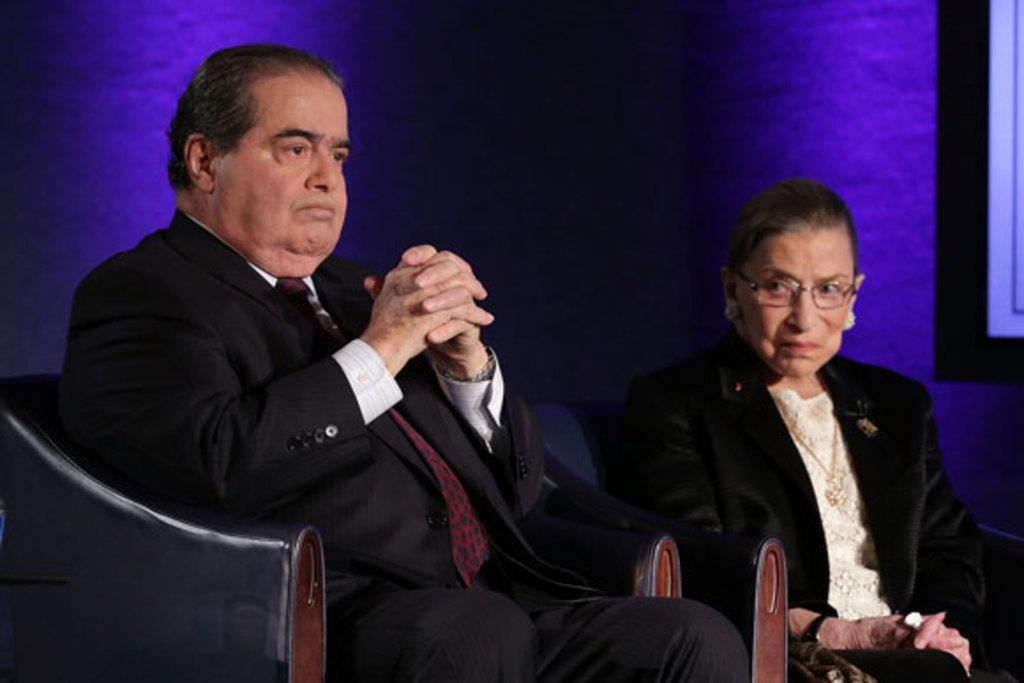Who are the people in the image? There is a man and a woman in the image. What are the man and woman doing in the image? Both the man and woman are sitting on chairs. What color is the background of the image? The background of the image is in blue color. How many cubs can be seen playing with the goldfish in the image? There are no cubs or goldfish present in the image. Are there any rabbits visible in the image? There are no rabbits visible in the image. 